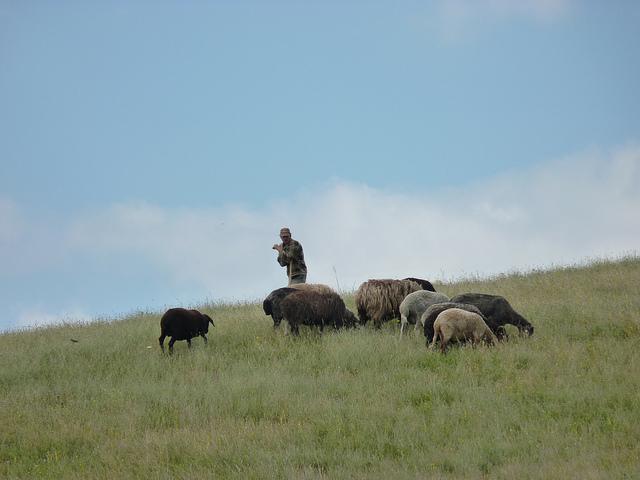Are the sheep sheared?
Short answer required. No. What is the green stuff the animals are eating?
Answer briefly. Grass. Where is the human?
Concise answer only. Standing. Are these animals typically utilized for long distance travel?
Answer briefly. No. What species of animal is in the photo?
Give a very brief answer. Sheep. 